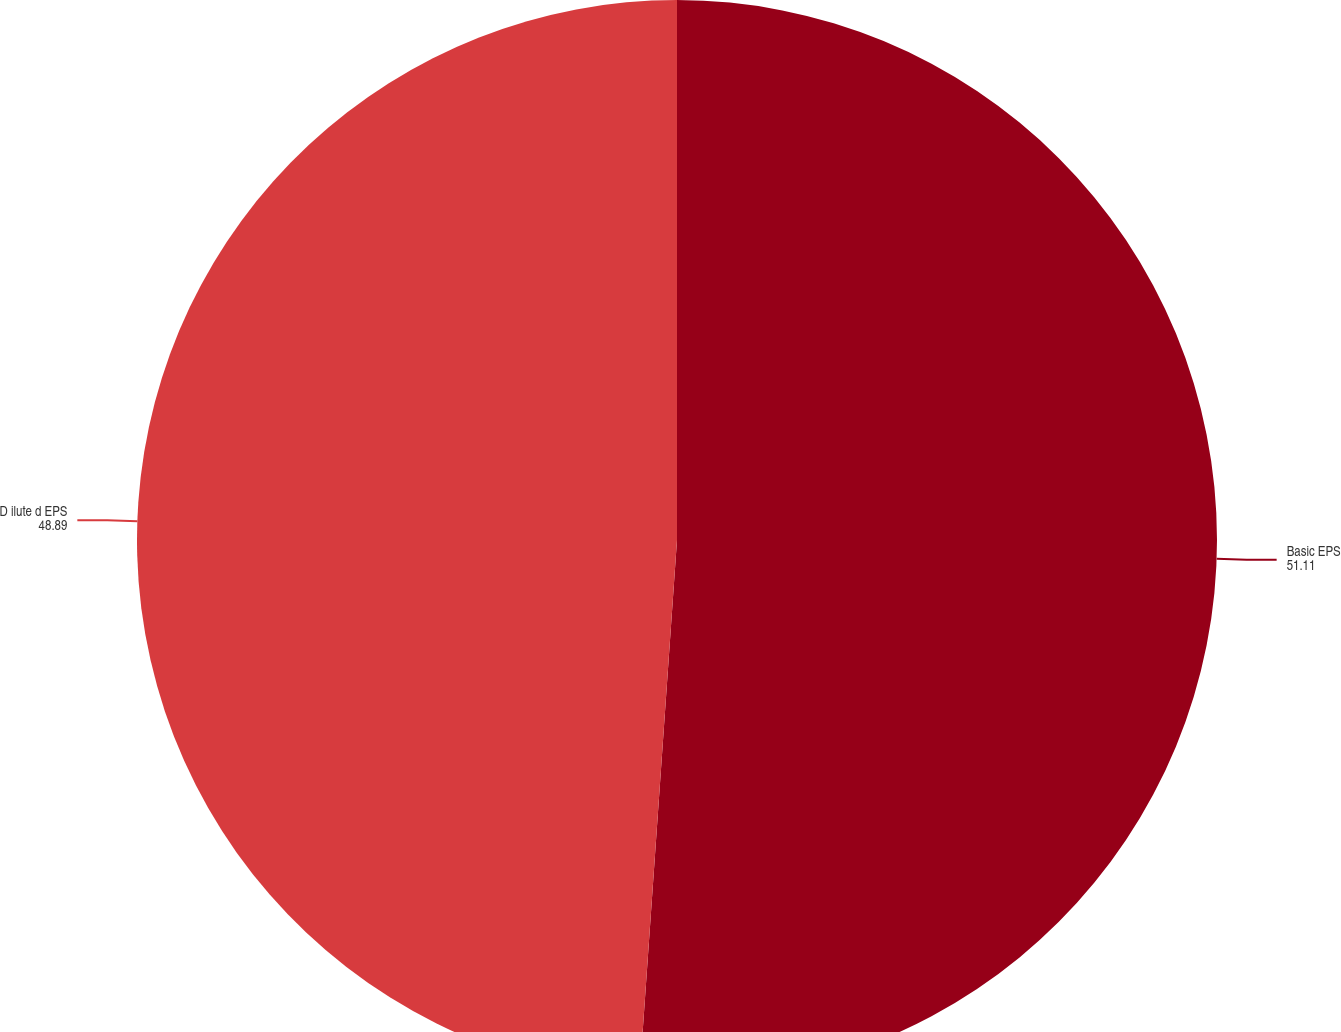Convert chart to OTSL. <chart><loc_0><loc_0><loc_500><loc_500><pie_chart><fcel>Basic EPS<fcel>D ilute d EPS<nl><fcel>51.11%<fcel>48.89%<nl></chart> 